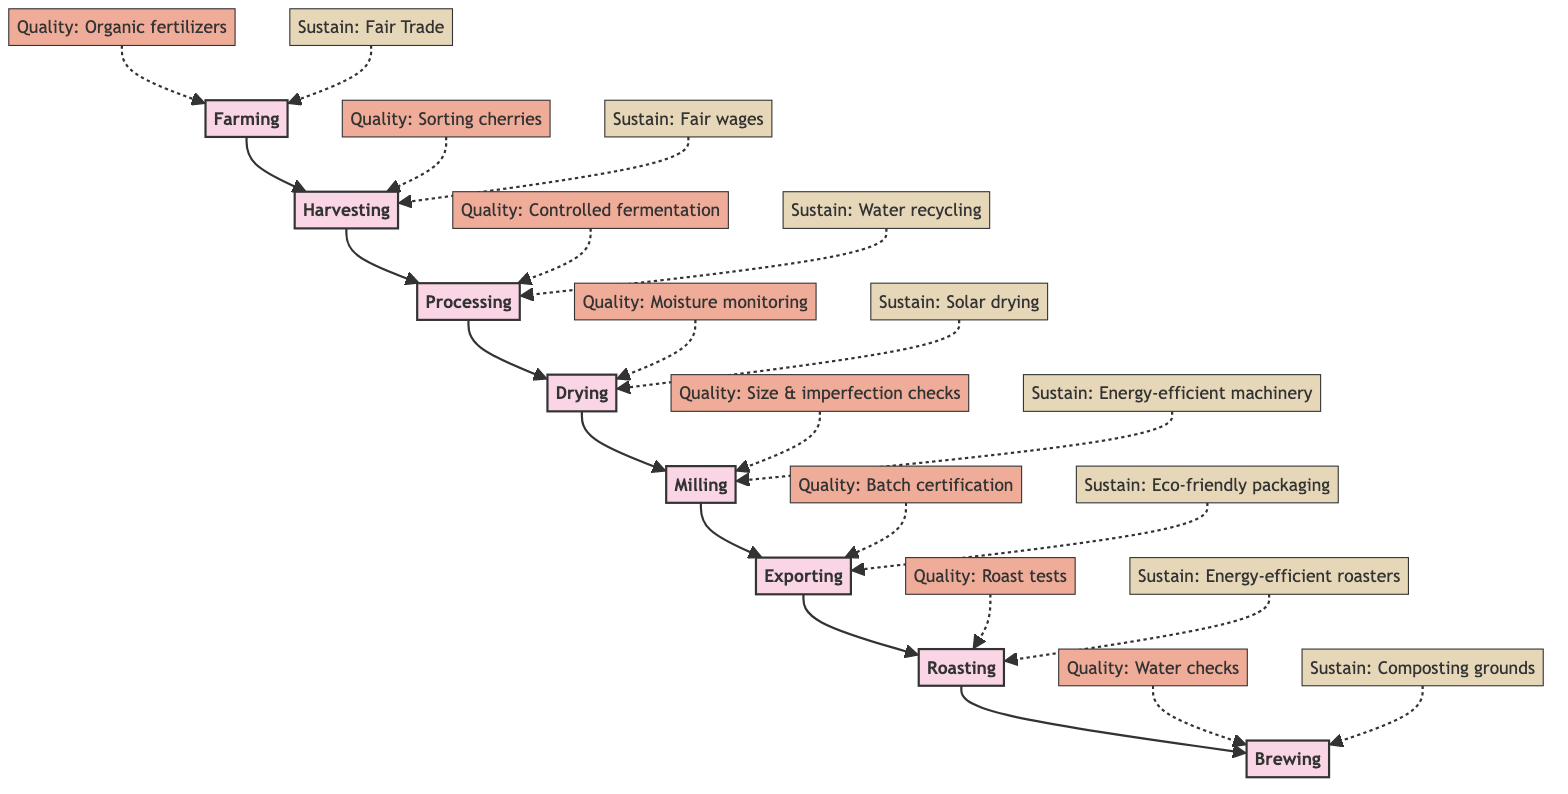What are the first two stages in coffee production? The diagram shows the stages in the journey of a coffee bean, starting from Farming followed by Harvesting.
Answer: Farming, Harvesting How many quality control measures are listed for drying? The drying stage has one quality control measure specified in the diagram, which is constant monitoring of moisture levels.
Answer: 1 Which stage has a sustainability measure related to local employment? The Harvesting stage includes the sustainability measure of local employment and fair wages.
Answer: Harvesting What is the primary processing method used in the processing stage? The processing stage describes wet processing as the main method to remove fruit layers from coffee cherries.
Answer: Wet processing Which stages have quality control measures focused on energy efficiency? The Milling and Roasting stages both highlight energy efficiency as part of their quality control measures. First, this is mentioned in the Milling stage through efficient machinery, and again in Roasting with energy-efficient roasters.
Answer: Milling, Roasting What sustainability practice is associated with the exporting stage? The diagram states that eco-friendly packaging is the sustainability practice related to the exporting stage.
Answer: Eco-friendly packaging How are coffee beans sorted after milling? After milling, coffee beans are sorted based on size and imperfections, which is highlighted in the quality control section of that stage.
Answer: Size & imperfections What is the focus of brewing quality control measures? The brewing stage focuses on water quality checks and precise measurements and brewing times, emphasizing the importance of both aspects in delivering the perfect cup.
Answer: Water quality checks, measurements Which stage features controlled fermentation as a quality control measure? During the processing stage, controlled fermentation is specifically highlighted as a quality control measure to ensure the proper processing of coffee cherries.
Answer: Processing 